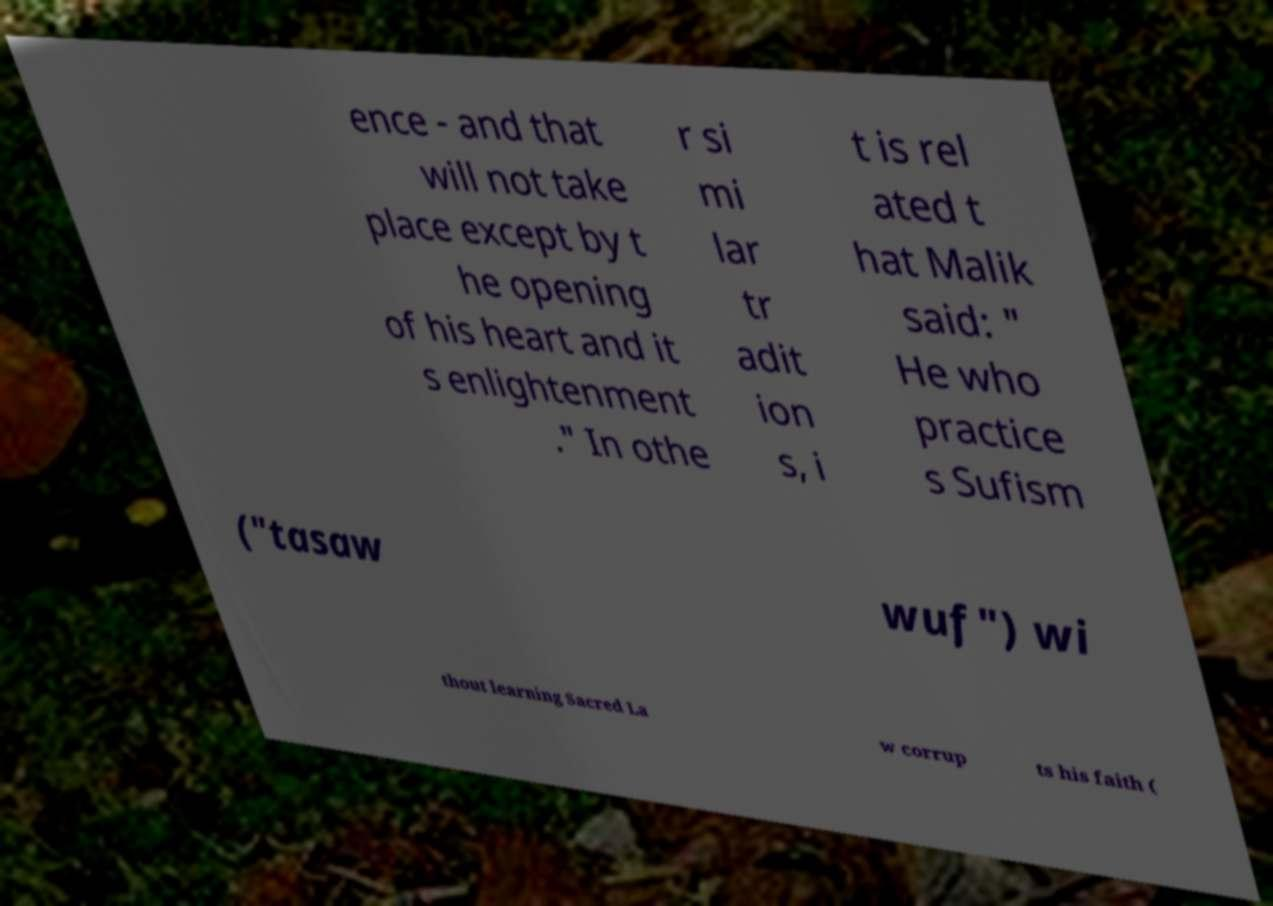What messages or text are displayed in this image? I need them in a readable, typed format. ence - and that will not take place except by t he opening of his heart and it s enlightenment ." In othe r si mi lar tr adit ion s, i t is rel ated t hat Malik said: " He who practice s Sufism ("tasaw wuf") wi thout learning Sacred La w corrup ts his faith ( 